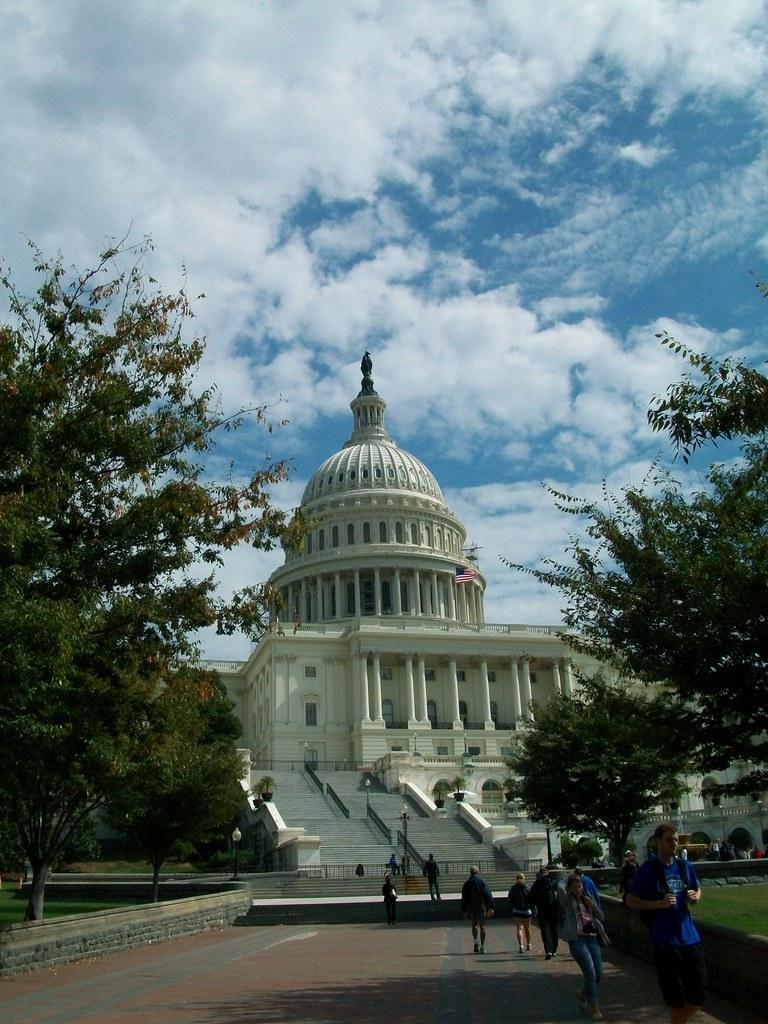How would you summarize this image in a sentence or two? In the foreground of the picture there are people walking. On the right there are plants, grass and tree. On the left there are trees, grass, wall and other objects. In the center of the background there is a building and staircases, and railings and flag. 